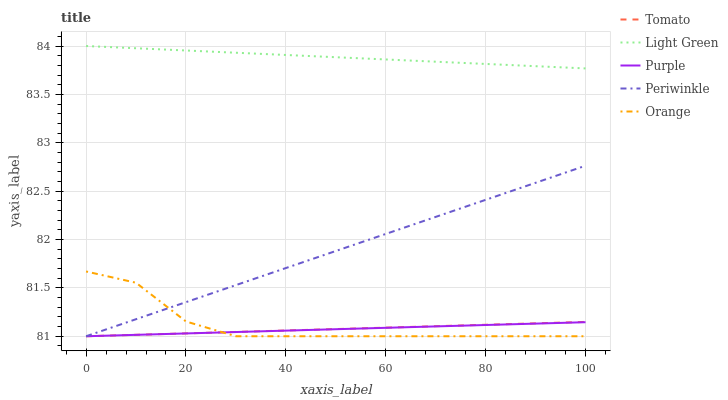Does Purple have the minimum area under the curve?
Answer yes or no. Yes. Does Light Green have the maximum area under the curve?
Answer yes or no. Yes. Does Orange have the minimum area under the curve?
Answer yes or no. No. Does Orange have the maximum area under the curve?
Answer yes or no. No. Is Tomato the smoothest?
Answer yes or no. Yes. Is Orange the roughest?
Answer yes or no. Yes. Is Purple the smoothest?
Answer yes or no. No. Is Purple the roughest?
Answer yes or no. No. Does Tomato have the lowest value?
Answer yes or no. Yes. Does Light Green have the lowest value?
Answer yes or no. No. Does Light Green have the highest value?
Answer yes or no. Yes. Does Orange have the highest value?
Answer yes or no. No. Is Orange less than Light Green?
Answer yes or no. Yes. Is Light Green greater than Purple?
Answer yes or no. Yes. Does Tomato intersect Orange?
Answer yes or no. Yes. Is Tomato less than Orange?
Answer yes or no. No. Is Tomato greater than Orange?
Answer yes or no. No. Does Orange intersect Light Green?
Answer yes or no. No. 